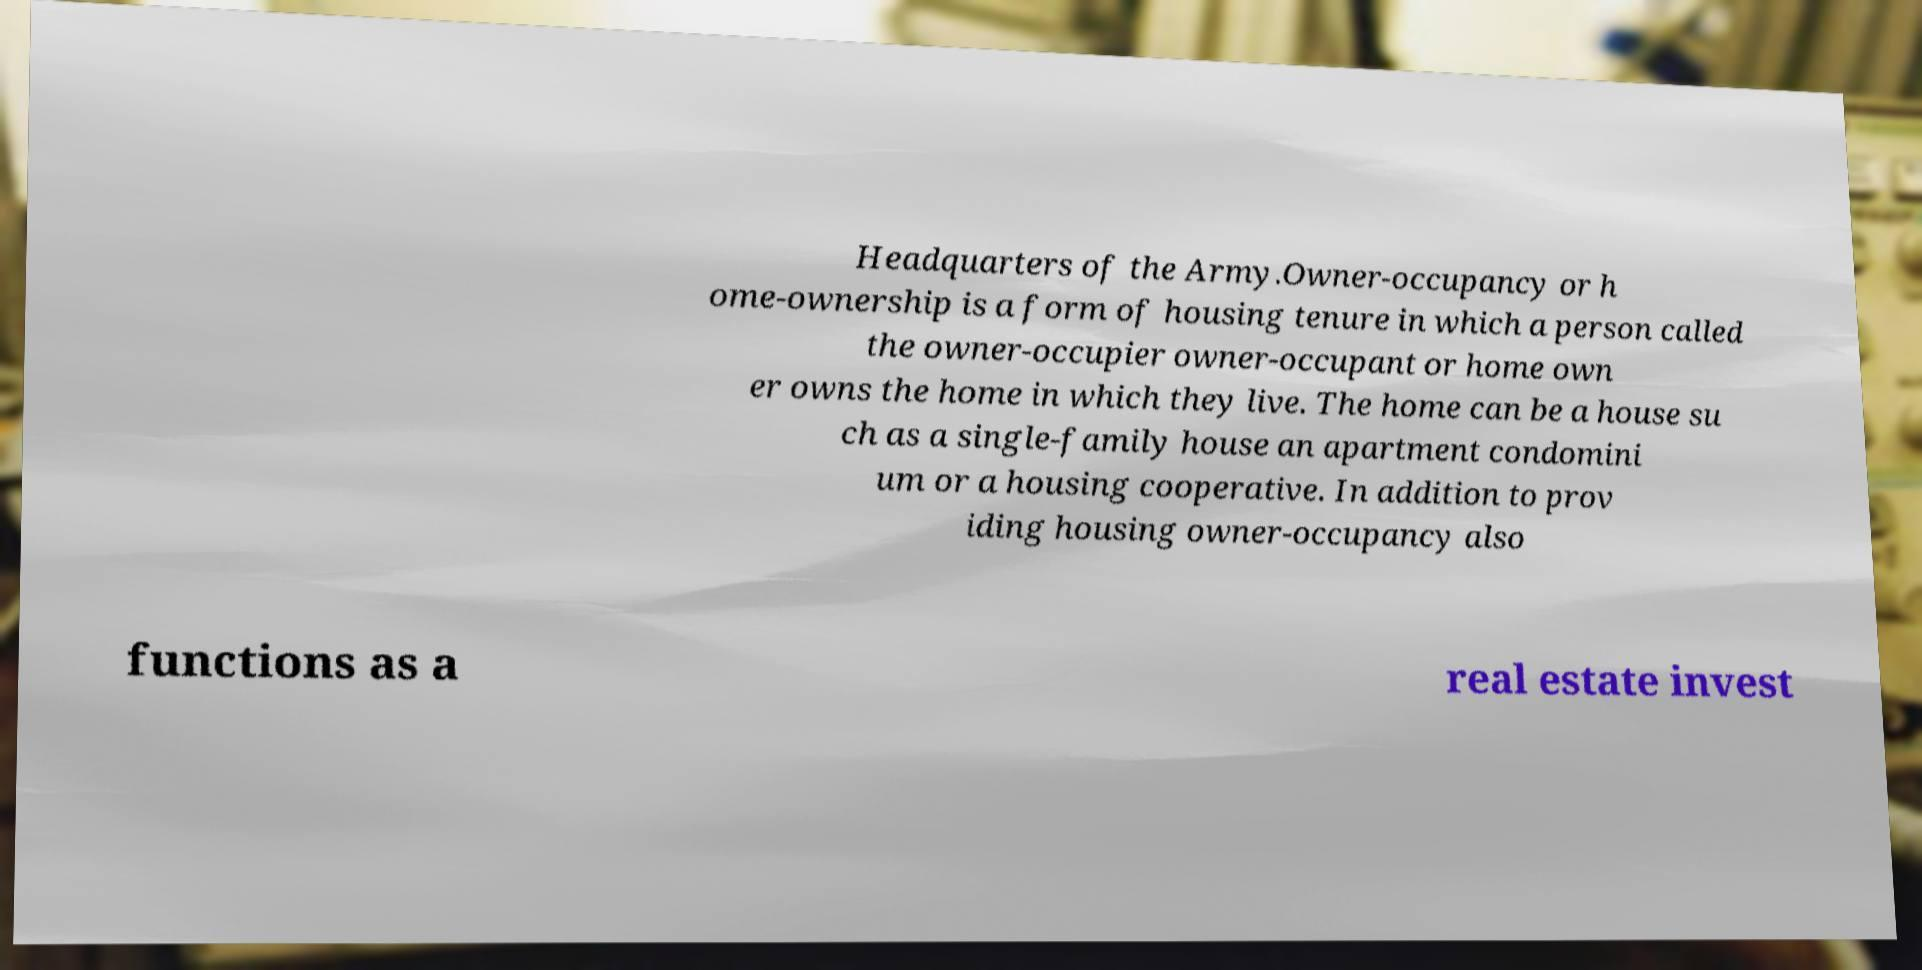Can you accurately transcribe the text from the provided image for me? Headquarters of the Army.Owner-occupancy or h ome-ownership is a form of housing tenure in which a person called the owner-occupier owner-occupant or home own er owns the home in which they live. The home can be a house su ch as a single-family house an apartment condomini um or a housing cooperative. In addition to prov iding housing owner-occupancy also functions as a real estate invest 